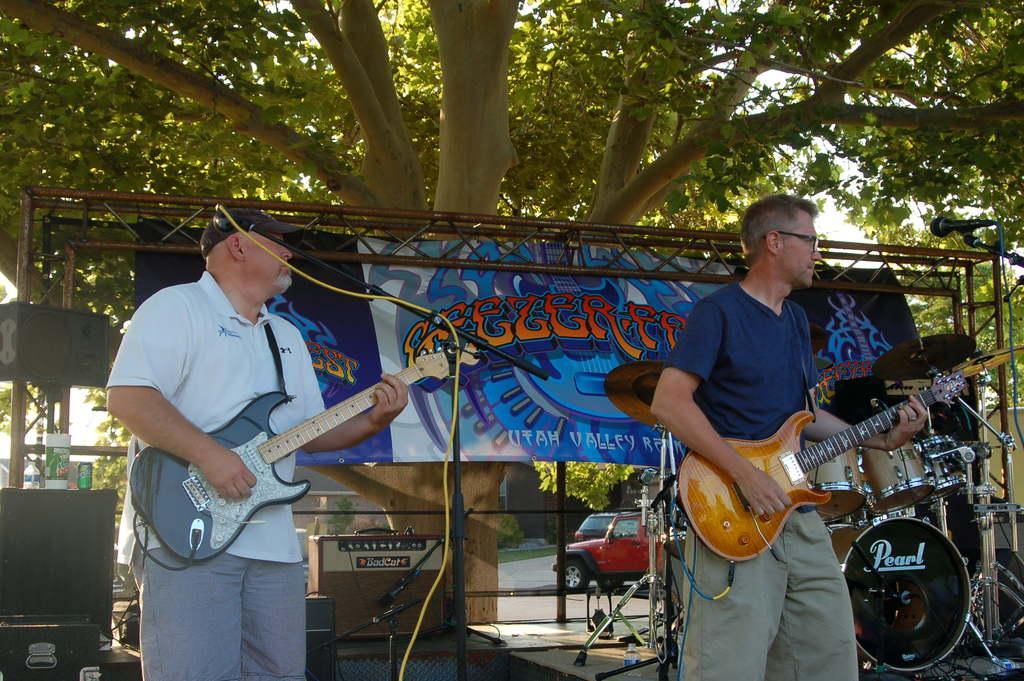How would you summarize this image in a sentence or two? There is a musical event is going on. These both are playing guitars. In the background, there is a big tree, sky, bar, road, grass, building, speaker and the box. There is a mic in the right hand side. 